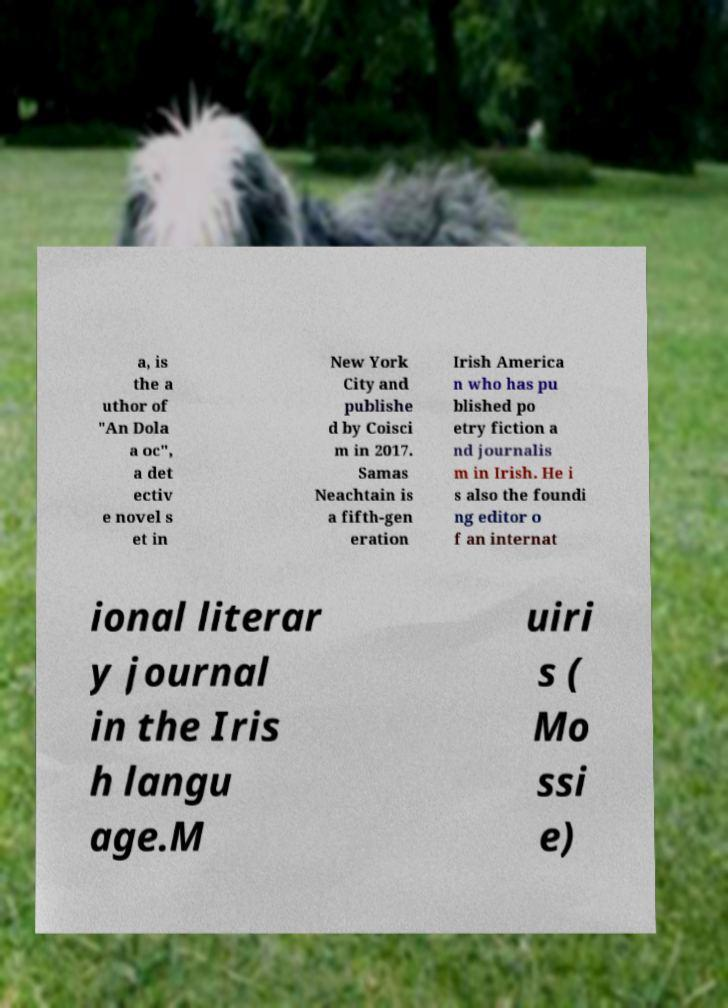What messages or text are displayed in this image? I need them in a readable, typed format. a, is the a uthor of "An Dola a oc", a det ectiv e novel s et in New York City and publishe d by Coisci m in 2017. Samas Neachtain is a fifth-gen eration Irish America n who has pu blished po etry fiction a nd journalis m in Irish. He i s also the foundi ng editor o f an internat ional literar y journal in the Iris h langu age.M uiri s ( Mo ssi e) 